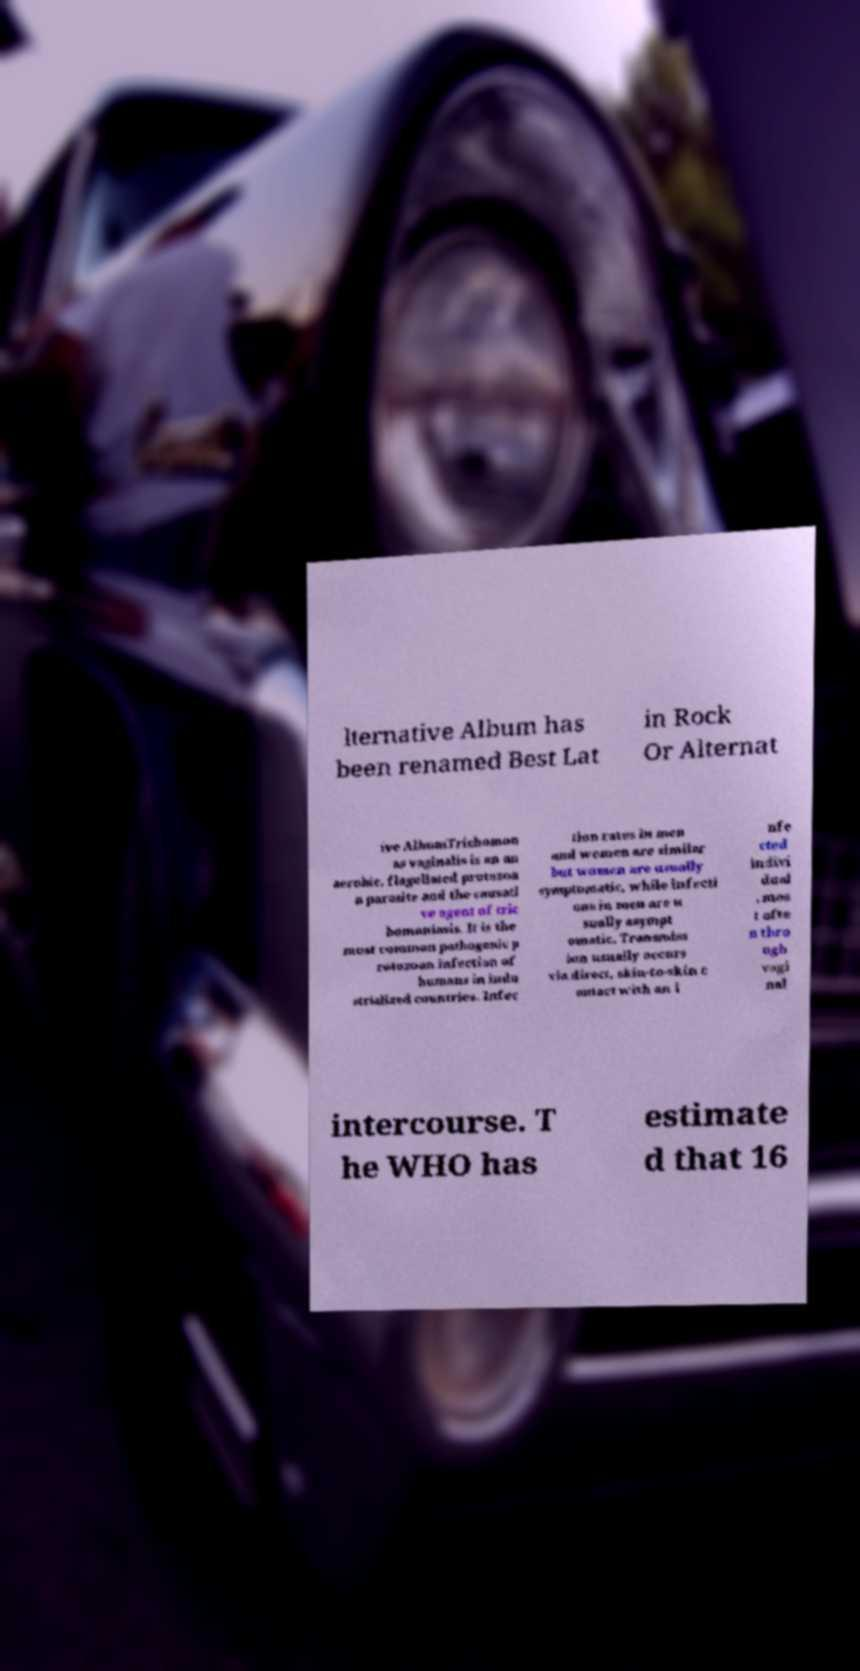Can you accurately transcribe the text from the provided image for me? lternative Album has been renamed Best Lat in Rock Or Alternat ive AlbumTrichomon as vaginalis is an an aerobic, flagellated protozoa n parasite and the causati ve agent of tric homoniasis. It is the most common pathogenic p rotozoan infection of humans in indu strialized countries. Infec tion rates in men and women are similar but women are usually symptomatic, while infecti ons in men are u sually asympt omatic. Transmiss ion usually occurs via direct, skin-to-skin c ontact with an i nfe cted indivi dual , mos t ofte n thro ugh vagi nal intercourse. T he WHO has estimate d that 16 